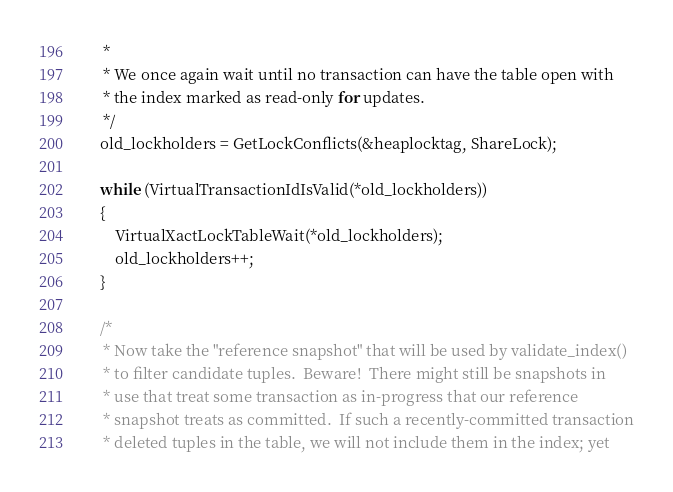<code> <loc_0><loc_0><loc_500><loc_500><_C_>	 *
	 * We once again wait until no transaction can have the table open with
	 * the index marked as read-only for updates.
	 */
	old_lockholders = GetLockConflicts(&heaplocktag, ShareLock);

	while (VirtualTransactionIdIsValid(*old_lockholders))
	{
		VirtualXactLockTableWait(*old_lockholders);
		old_lockholders++;
	}

	/*
	 * Now take the "reference snapshot" that will be used by validate_index()
	 * to filter candidate tuples.  Beware!  There might still be snapshots in
	 * use that treat some transaction as in-progress that our reference
	 * snapshot treats as committed.  If such a recently-committed transaction
	 * deleted tuples in the table, we will not include them in the index; yet</code> 